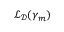<formula> <loc_0><loc_0><loc_500><loc_500>\mathcal { L } _ { \mathcal { D } } ( \gamma _ { m } )</formula> 